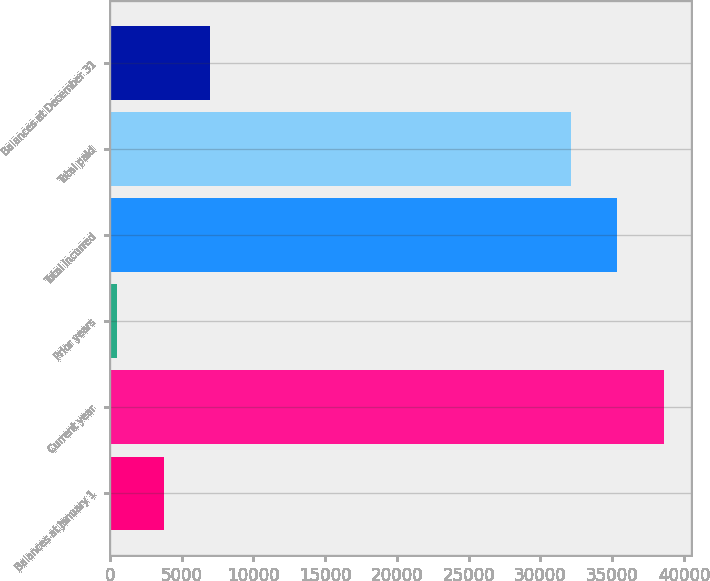<chart> <loc_0><loc_0><loc_500><loc_500><bar_chart><fcel>Balances at January 1<fcel>Current year<fcel>Prior years<fcel>Total incurred<fcel>Total paid<fcel>Balances at December 31<nl><fcel>3775<fcel>38571.4<fcel>474<fcel>35347.7<fcel>32124<fcel>6998.7<nl></chart> 